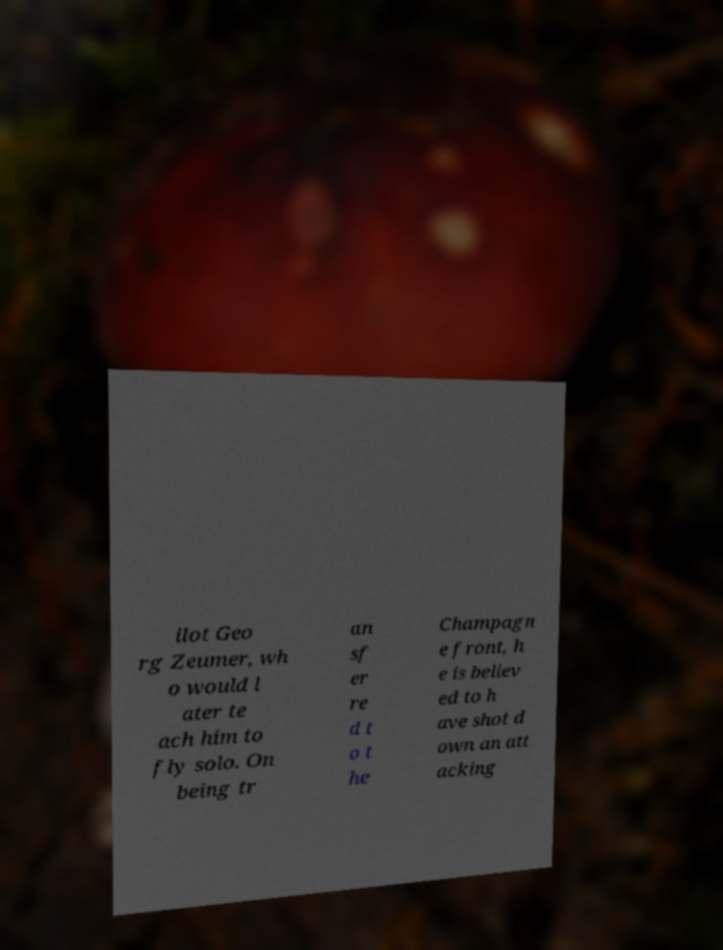There's text embedded in this image that I need extracted. Can you transcribe it verbatim? ilot Geo rg Zeumer, wh o would l ater te ach him to fly solo. On being tr an sf er re d t o t he Champagn e front, h e is believ ed to h ave shot d own an att acking 